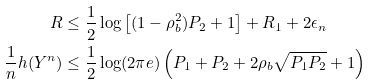Convert formula to latex. <formula><loc_0><loc_0><loc_500><loc_500>R & \leq \frac { 1 } { 2 } \log \left [ ( 1 - \rho _ { b } ^ { 2 } ) P _ { 2 } + 1 \right ] + R _ { 1 } + 2 \epsilon _ { n } \\ \frac { 1 } { n } h ( Y ^ { n } ) & \leq \frac { 1 } { 2 } \log ( 2 \pi e ) \left ( P _ { 1 } + P _ { 2 } + 2 \rho _ { b } \sqrt { P _ { 1 } P _ { 2 } } + 1 \right )</formula> 